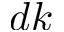<formula> <loc_0><loc_0><loc_500><loc_500>d k</formula> 